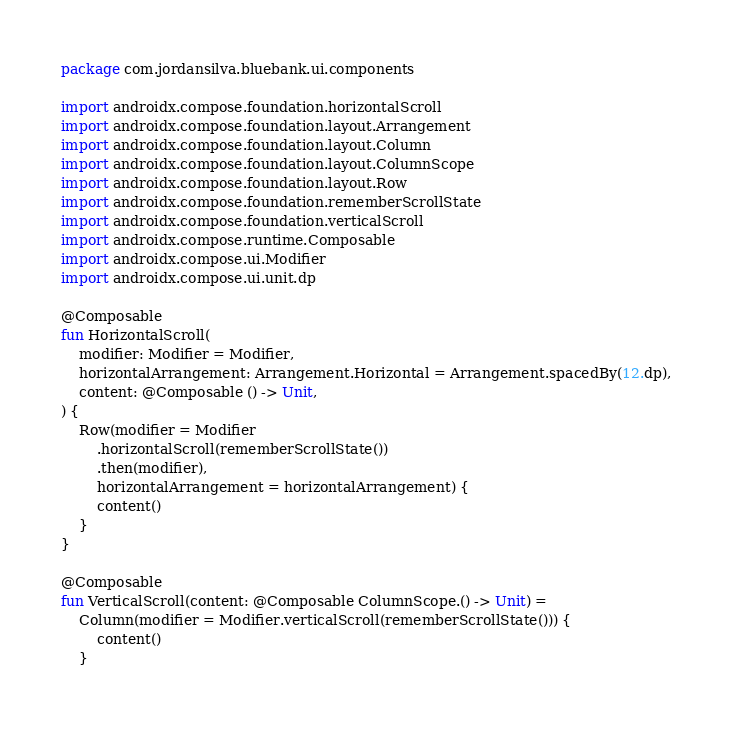Convert code to text. <code><loc_0><loc_0><loc_500><loc_500><_Kotlin_>package com.jordansilva.bluebank.ui.components

import androidx.compose.foundation.horizontalScroll
import androidx.compose.foundation.layout.Arrangement
import androidx.compose.foundation.layout.Column
import androidx.compose.foundation.layout.ColumnScope
import androidx.compose.foundation.layout.Row
import androidx.compose.foundation.rememberScrollState
import androidx.compose.foundation.verticalScroll
import androidx.compose.runtime.Composable
import androidx.compose.ui.Modifier
import androidx.compose.ui.unit.dp

@Composable
fun HorizontalScroll(
    modifier: Modifier = Modifier,
    horizontalArrangement: Arrangement.Horizontal = Arrangement.spacedBy(12.dp),
    content: @Composable () -> Unit,
) {
    Row(modifier = Modifier
        .horizontalScroll(rememberScrollState())
        .then(modifier),
        horizontalArrangement = horizontalArrangement) {
        content()
    }
}

@Composable
fun VerticalScroll(content: @Composable ColumnScope.() -> Unit) =
    Column(modifier = Modifier.verticalScroll(rememberScrollState())) {
        content()
    }
</code> 